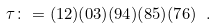Convert formula to latex. <formula><loc_0><loc_0><loc_500><loc_500>\tau \colon = ( 1 2 ) ( 0 3 ) ( 9 4 ) ( 8 5 ) ( 7 6 ) \ .</formula> 